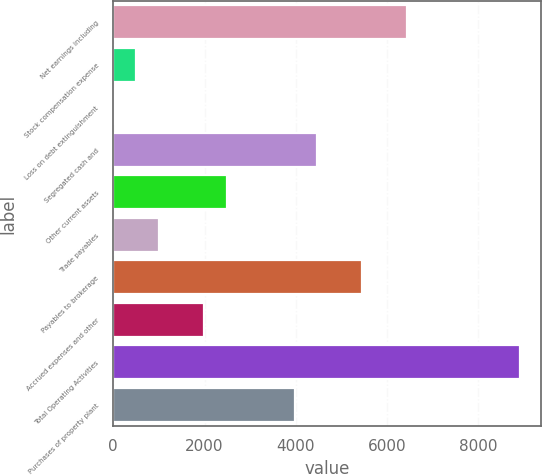Convert chart to OTSL. <chart><loc_0><loc_0><loc_500><loc_500><bar_chart><fcel>Net earnings including<fcel>Stock compensation expense<fcel>Loss on debt extinguishment<fcel>Segregated cash and<fcel>Other current assets<fcel>Trade payables<fcel>Payables to brokerage<fcel>Accrued expenses and other<fcel>Total Operating Activities<fcel>Purchases of property plant<nl><fcel>6446.7<fcel>507.9<fcel>13<fcel>4467.1<fcel>2487.5<fcel>1002.8<fcel>5456.9<fcel>1992.6<fcel>8921.2<fcel>3972.2<nl></chart> 